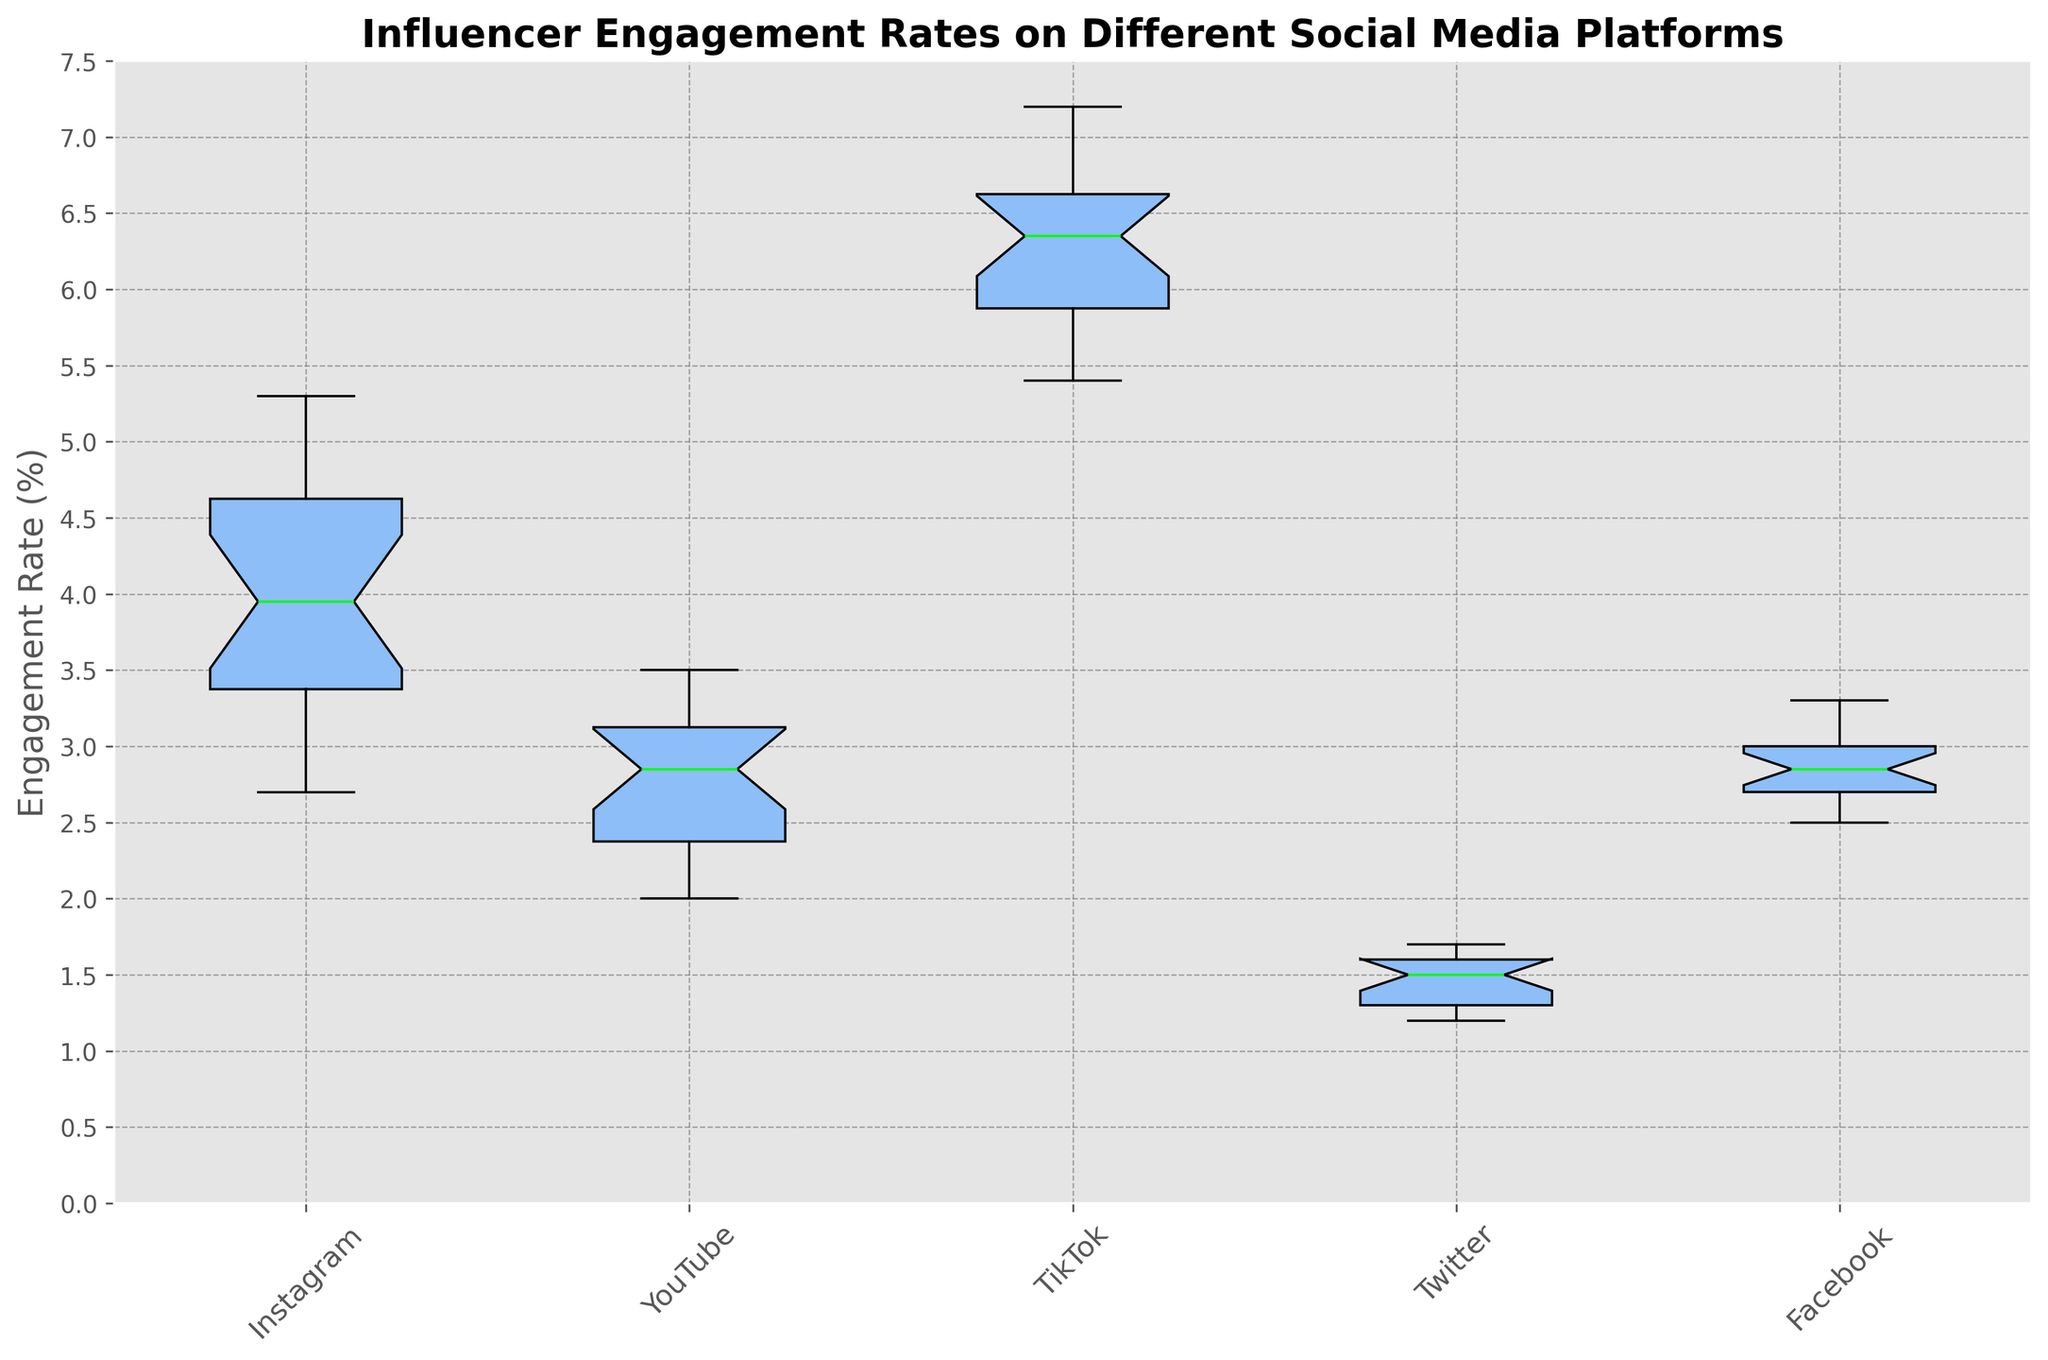What's the median engagement rate for TikTok? To find the median, look at the middle value of the sorted data for TikTok. Since there are 20 values, the median will be the average of the 10th and 11th values. From visual inspection, the box’s horizontal line within TikTok's box represents the median.
Answer: 6.5% Which platform has the highest median engagement rate? To answer this, compare the heights of the medians (horizontal lines inside each box) among different platforms. TikTok’s median is the highest.
Answer: TikTok How does the range of YouTube's engagement rates compare to Instagram's? The range can be determined by subtracting the minimum value (lower whisker) from the maximum value (upper whisker). Compare the ranges visually by noting the span of the whiskers for YouTube and Instagram. YouTube has a narrower range compared to Instagram.
Answer: Instagram has a wider range What percentage of TikTok engagement rates are below 6%? On a box plot, the bottom 25% of values are below the lower quartile (bottom edge of the box). For TikTok, this lower edge appears to be at about 6%.
Answer: 25% Which platform has the smallest interquartile range (IQR)? The IQR is the height of the box (distance between the upper and lower quartiles). Visually compare the heights of the boxes among all platforms. Twitter’s box is the smallest.
Answer: Twitter What is the difference between the median engagement rates of Instagram and Facebook? Locate the medians (horizontal lines inside the boxes) of Instagram and Facebook. Instagram’s median is about 4%, and Facebook’s median is around 2.9%. Subtract 2.9 from 4.
Answer: 1.1% What is the maximum engagement rate observed on Twitter? The upper whisker indicates the maximum value. Observe the highest point of the whisker on Twitter's box.
Answer: 1.7% Which platform has the most variability in engagement rates? Variability can be inferred from the length of the whiskers and the spread of the data points. Examine the overall height from the lowest whisker to the highest whisker. Instagram shows the most variability with a wider spread.
Answer: Instagram 